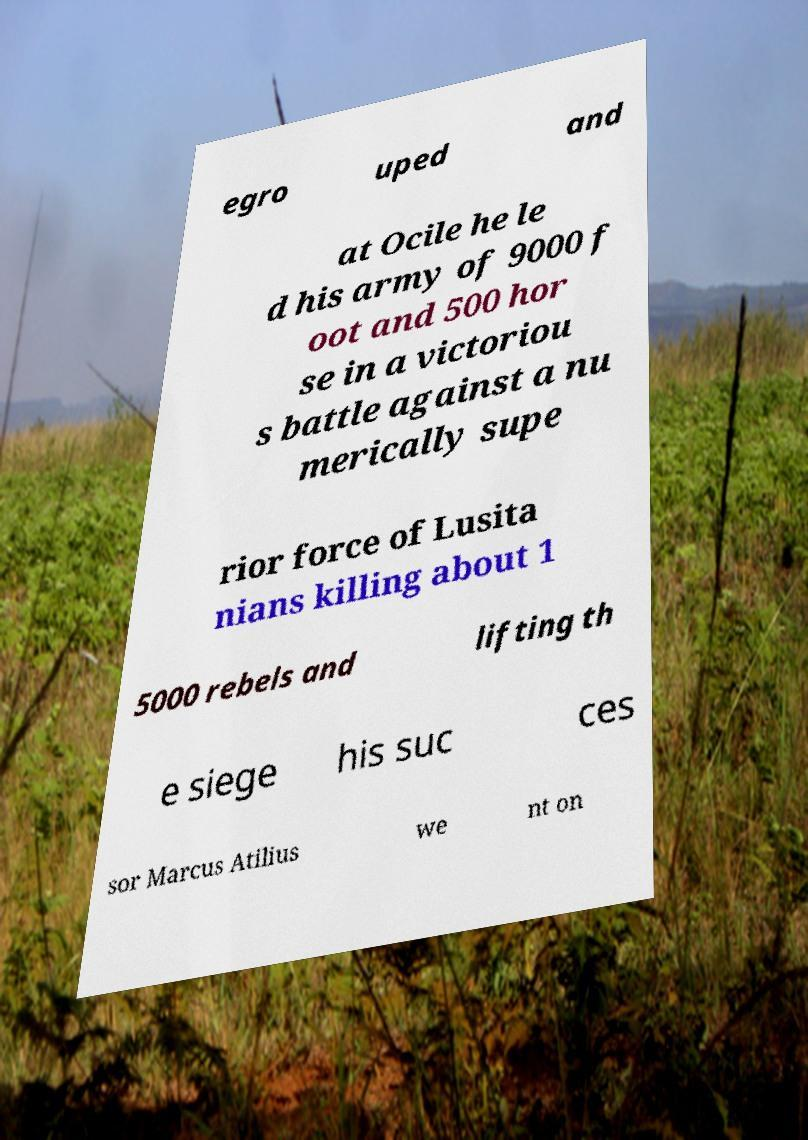Can you accurately transcribe the text from the provided image for me? egro uped and at Ocile he le d his army of 9000 f oot and 500 hor se in a victoriou s battle against a nu merically supe rior force of Lusita nians killing about 1 5000 rebels and lifting th e siege his suc ces sor Marcus Atilius we nt on 